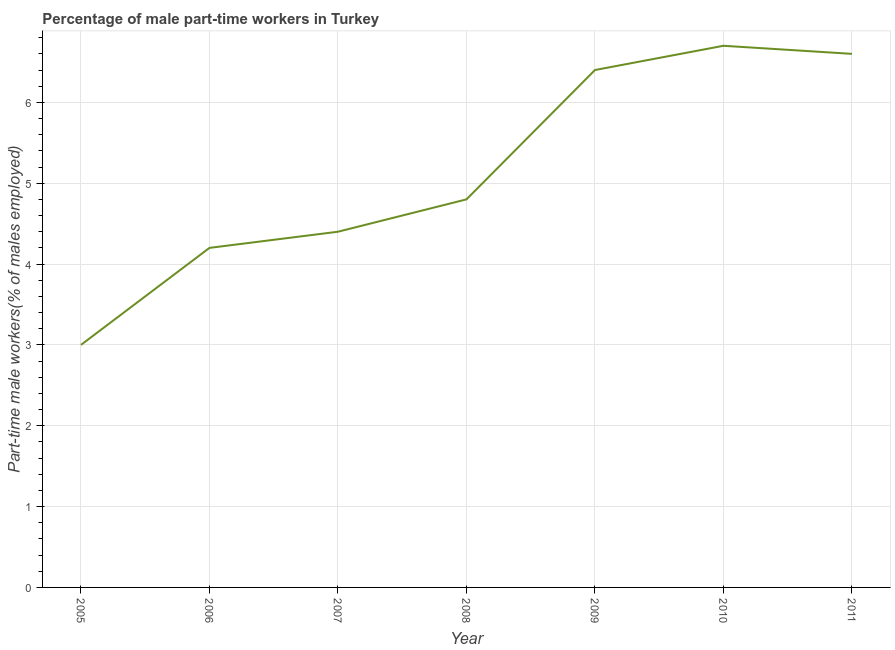What is the percentage of part-time male workers in 2011?
Your answer should be compact. 6.6. Across all years, what is the maximum percentage of part-time male workers?
Provide a succinct answer. 6.7. Across all years, what is the minimum percentage of part-time male workers?
Your answer should be compact. 3. In which year was the percentage of part-time male workers maximum?
Offer a terse response. 2010. What is the sum of the percentage of part-time male workers?
Ensure brevity in your answer.  36.1. What is the difference between the percentage of part-time male workers in 2006 and 2008?
Your answer should be compact. -0.6. What is the average percentage of part-time male workers per year?
Provide a succinct answer. 5.16. What is the median percentage of part-time male workers?
Provide a short and direct response. 4.8. Do a majority of the years between 2009 and 2007 (inclusive) have percentage of part-time male workers greater than 1.6 %?
Give a very brief answer. No. What is the ratio of the percentage of part-time male workers in 2005 to that in 2008?
Provide a succinct answer. 0.62. Is the percentage of part-time male workers in 2007 less than that in 2010?
Your response must be concise. Yes. What is the difference between the highest and the second highest percentage of part-time male workers?
Offer a very short reply. 0.1. What is the difference between the highest and the lowest percentage of part-time male workers?
Your response must be concise. 3.7. In how many years, is the percentage of part-time male workers greater than the average percentage of part-time male workers taken over all years?
Provide a short and direct response. 3. How many lines are there?
Provide a succinct answer. 1. What is the title of the graph?
Your answer should be compact. Percentage of male part-time workers in Turkey. What is the label or title of the X-axis?
Ensure brevity in your answer.  Year. What is the label or title of the Y-axis?
Your answer should be compact. Part-time male workers(% of males employed). What is the Part-time male workers(% of males employed) in 2006?
Your answer should be compact. 4.2. What is the Part-time male workers(% of males employed) in 2007?
Keep it short and to the point. 4.4. What is the Part-time male workers(% of males employed) of 2008?
Your answer should be very brief. 4.8. What is the Part-time male workers(% of males employed) in 2009?
Your answer should be very brief. 6.4. What is the Part-time male workers(% of males employed) in 2010?
Your answer should be compact. 6.7. What is the Part-time male workers(% of males employed) of 2011?
Offer a very short reply. 6.6. What is the difference between the Part-time male workers(% of males employed) in 2005 and 2006?
Your answer should be compact. -1.2. What is the difference between the Part-time male workers(% of males employed) in 2005 and 2009?
Offer a terse response. -3.4. What is the difference between the Part-time male workers(% of males employed) in 2005 and 2010?
Provide a short and direct response. -3.7. What is the difference between the Part-time male workers(% of males employed) in 2005 and 2011?
Your response must be concise. -3.6. What is the difference between the Part-time male workers(% of males employed) in 2006 and 2007?
Give a very brief answer. -0.2. What is the difference between the Part-time male workers(% of males employed) in 2006 and 2008?
Make the answer very short. -0.6. What is the difference between the Part-time male workers(% of males employed) in 2007 and 2008?
Your answer should be compact. -0.4. What is the difference between the Part-time male workers(% of males employed) in 2007 and 2009?
Keep it short and to the point. -2. What is the difference between the Part-time male workers(% of males employed) in 2007 and 2010?
Make the answer very short. -2.3. What is the difference between the Part-time male workers(% of males employed) in 2008 and 2009?
Give a very brief answer. -1.6. What is the difference between the Part-time male workers(% of males employed) in 2008 and 2010?
Provide a succinct answer. -1.9. What is the difference between the Part-time male workers(% of males employed) in 2009 and 2010?
Provide a short and direct response. -0.3. What is the difference between the Part-time male workers(% of males employed) in 2010 and 2011?
Your response must be concise. 0.1. What is the ratio of the Part-time male workers(% of males employed) in 2005 to that in 2006?
Your answer should be compact. 0.71. What is the ratio of the Part-time male workers(% of males employed) in 2005 to that in 2007?
Offer a very short reply. 0.68. What is the ratio of the Part-time male workers(% of males employed) in 2005 to that in 2009?
Your answer should be compact. 0.47. What is the ratio of the Part-time male workers(% of males employed) in 2005 to that in 2010?
Make the answer very short. 0.45. What is the ratio of the Part-time male workers(% of males employed) in 2005 to that in 2011?
Provide a succinct answer. 0.46. What is the ratio of the Part-time male workers(% of males employed) in 2006 to that in 2007?
Offer a terse response. 0.95. What is the ratio of the Part-time male workers(% of males employed) in 2006 to that in 2009?
Your response must be concise. 0.66. What is the ratio of the Part-time male workers(% of males employed) in 2006 to that in 2010?
Your answer should be very brief. 0.63. What is the ratio of the Part-time male workers(% of males employed) in 2006 to that in 2011?
Offer a very short reply. 0.64. What is the ratio of the Part-time male workers(% of males employed) in 2007 to that in 2008?
Give a very brief answer. 0.92. What is the ratio of the Part-time male workers(% of males employed) in 2007 to that in 2009?
Ensure brevity in your answer.  0.69. What is the ratio of the Part-time male workers(% of males employed) in 2007 to that in 2010?
Your response must be concise. 0.66. What is the ratio of the Part-time male workers(% of males employed) in 2007 to that in 2011?
Ensure brevity in your answer.  0.67. What is the ratio of the Part-time male workers(% of males employed) in 2008 to that in 2010?
Give a very brief answer. 0.72. What is the ratio of the Part-time male workers(% of males employed) in 2008 to that in 2011?
Offer a very short reply. 0.73. What is the ratio of the Part-time male workers(% of males employed) in 2009 to that in 2010?
Provide a succinct answer. 0.95. What is the ratio of the Part-time male workers(% of males employed) in 2009 to that in 2011?
Your response must be concise. 0.97. 